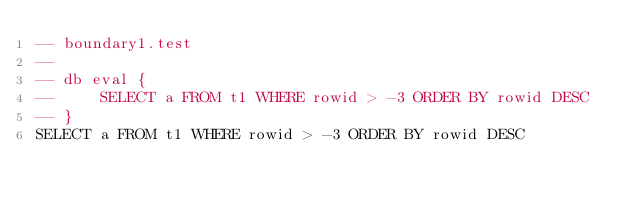<code> <loc_0><loc_0><loc_500><loc_500><_SQL_>-- boundary1.test
-- 
-- db eval {
--     SELECT a FROM t1 WHERE rowid > -3 ORDER BY rowid DESC
-- }
SELECT a FROM t1 WHERE rowid > -3 ORDER BY rowid DESC</code> 